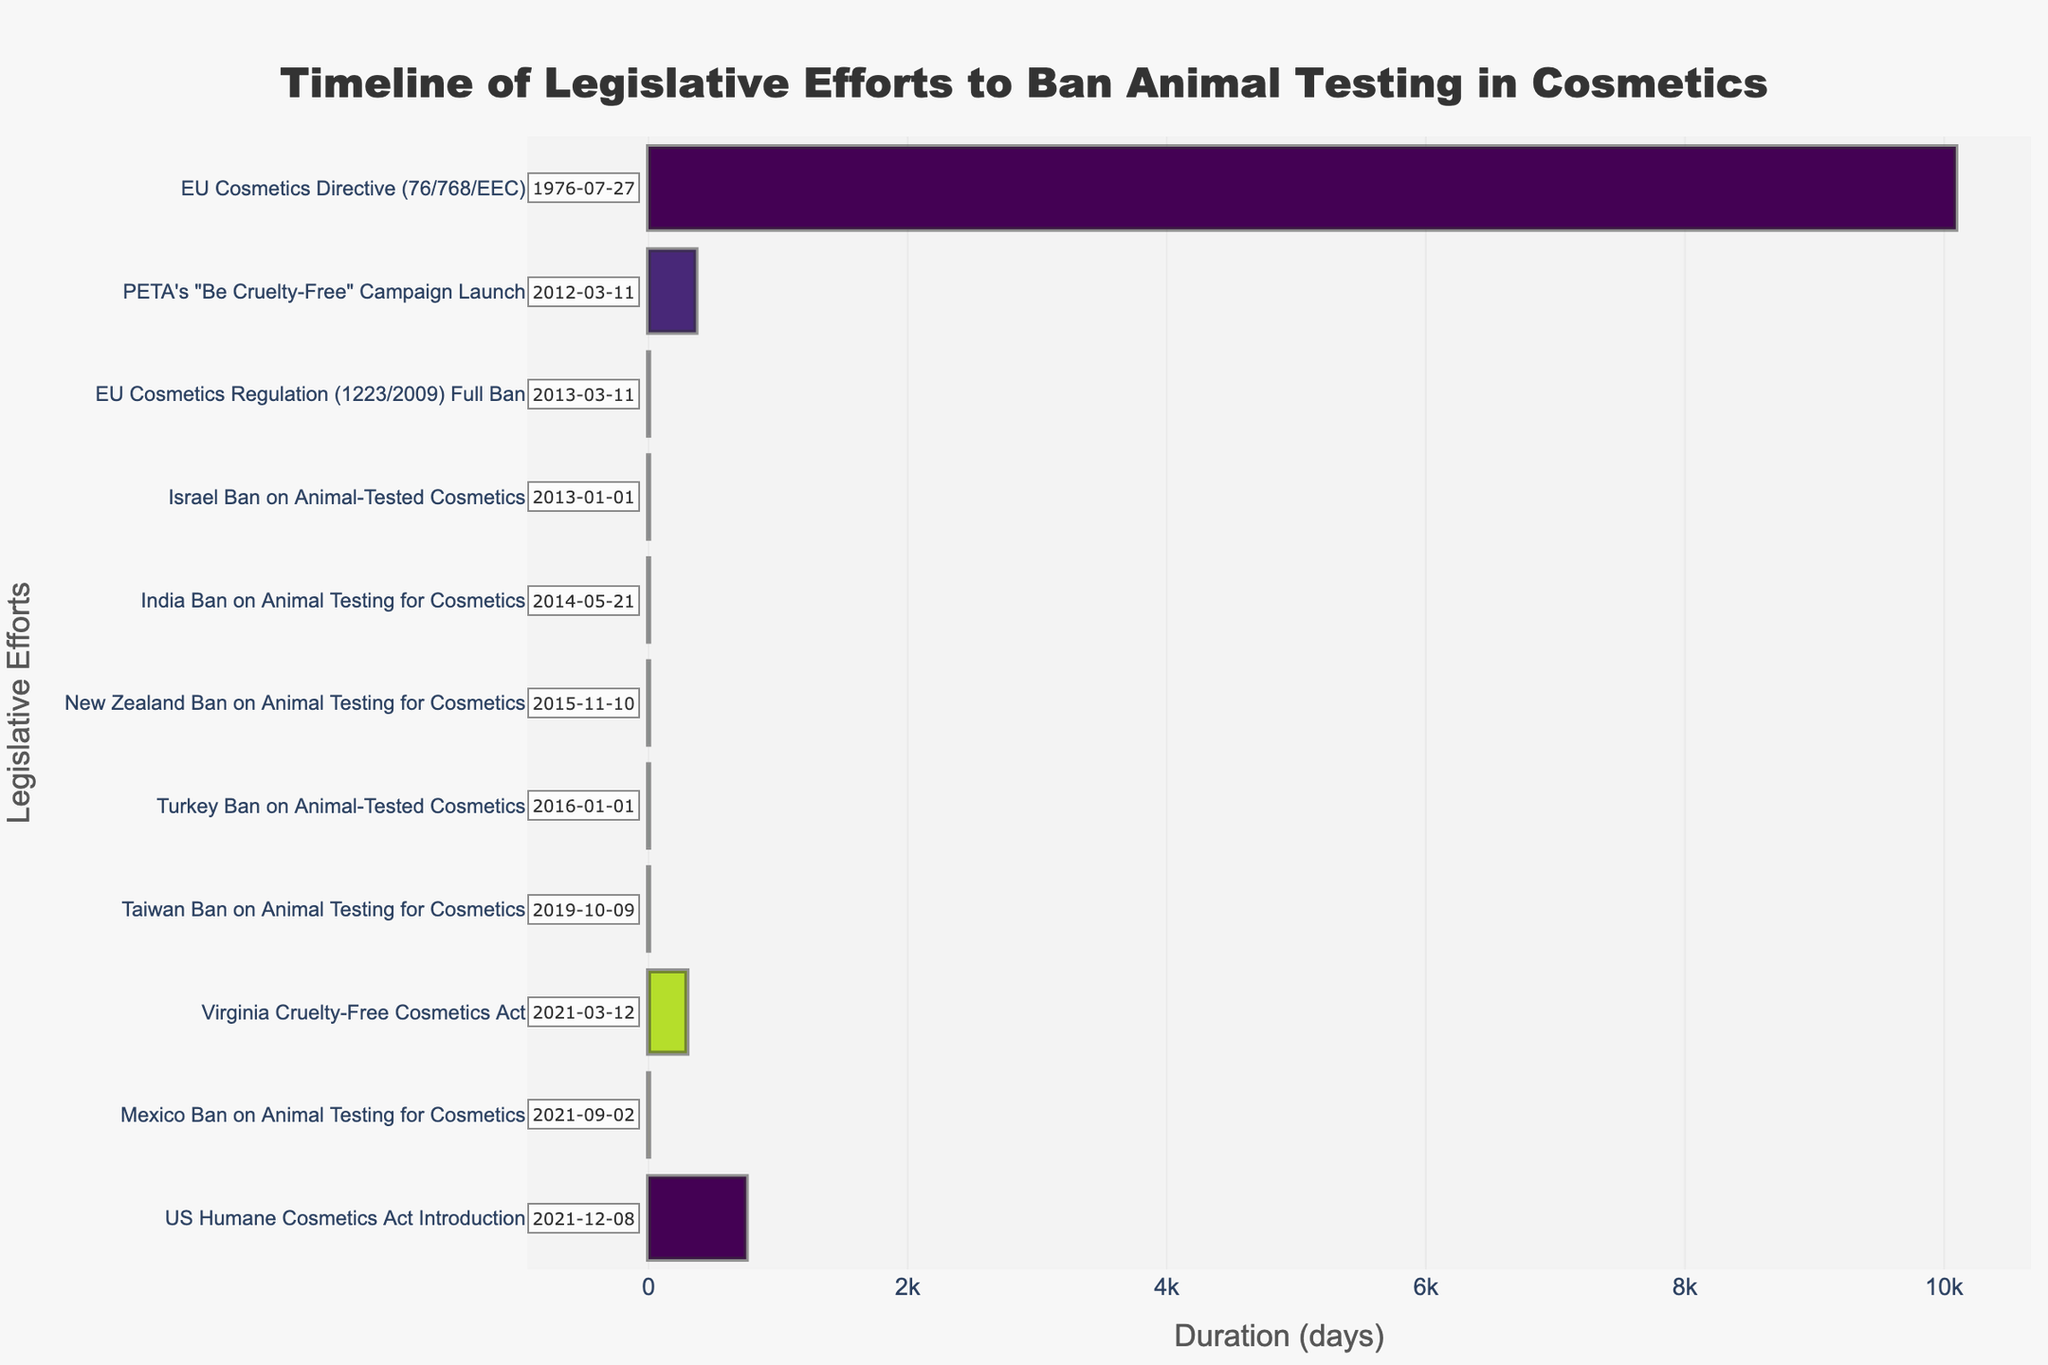Which legislative effort took the longest duration based on the Gantt chart? The Gantt chart shows the duration of each effort with horizontal bars. The longest bar indicates the EU Cosmetics Directive (76/768/EEC), which spans from 1976-07-27 to 2004-03-11
Answer: EU Cosmetics Directive (76/768/EEC) What is the end date of the EU Cosmetics Regulation (1223/2009) Full Ban in the Gantt chart? The Gantt chart provides start and end dates for each legislative effort. The end date of the EU Cosmetics Regulation (1223/2009) Full Ban is shown as 2013-03-11
Answer: 2013-03-11 How many legislative efforts are shown between 2013 and 2016? The Gantt chart shows efforts with their corresponding dates. Counting initiatives between 2013 and 2016, we see Israel Ban, EU Cosmetics Regulation Full Ban, India Ban, New Zealand Ban, and Turkey Ban.
Answer: 5 Which legislative efforts were initiated in 2021? By looking at the start dates on the Gantt chart, the legislative efforts initiated in 2021 are the Virginia Cruelty-Free Cosmetics Act, Mexico Ban on Animal Testing for Cosmetics, and US Humane Cosmetics Act Introduction
Answer: Virginia Cruelty-Free Cosmetics Act, Mexico Ban on Animal Testing for Cosmetics, US Humane Cosmetics Act Introduction What is the duration of the PETA's "Be Cruelty-Free" Campaign Launch? The PETA’s "Be Cruelty-Free" Campaign Launch spans from 2012-03-11 to 2013-03-11 which shows a duration of 1 year or 365 days
Answer: 365 days How does the duration of the Israel Ban on Animal-Tested Cosmetics compare to the India Ban on Animal Testing for Cosmetics? The Israel Ban on Animal-Tested Cosmetics and the India Ban on Animal Testing for Cosmetics are both shown as completed on a single day (instantaneous events), so they have the same duration.
Answer: Equal Which legislative effort is shown to end last on the timeline? Observing the end dates on the Gantt chart, the US Humane Cosmetics Act Introduction ends last, on 2023-12-31
Answer: US Humane Cosmetics Act Introduction What is the spread of dates between the earliest and the latest legislative efforts shown on the Gantt chart? The earliest date on the chart is the start of the EU Cosmetics Directive (76/768/EEC) on 1976-07-27 and the latest end date is the US Humane Cosmetics Act on 2023-12-31. The spread of dates is from 1976 to 2023.
Answer: 1976 to 2023 